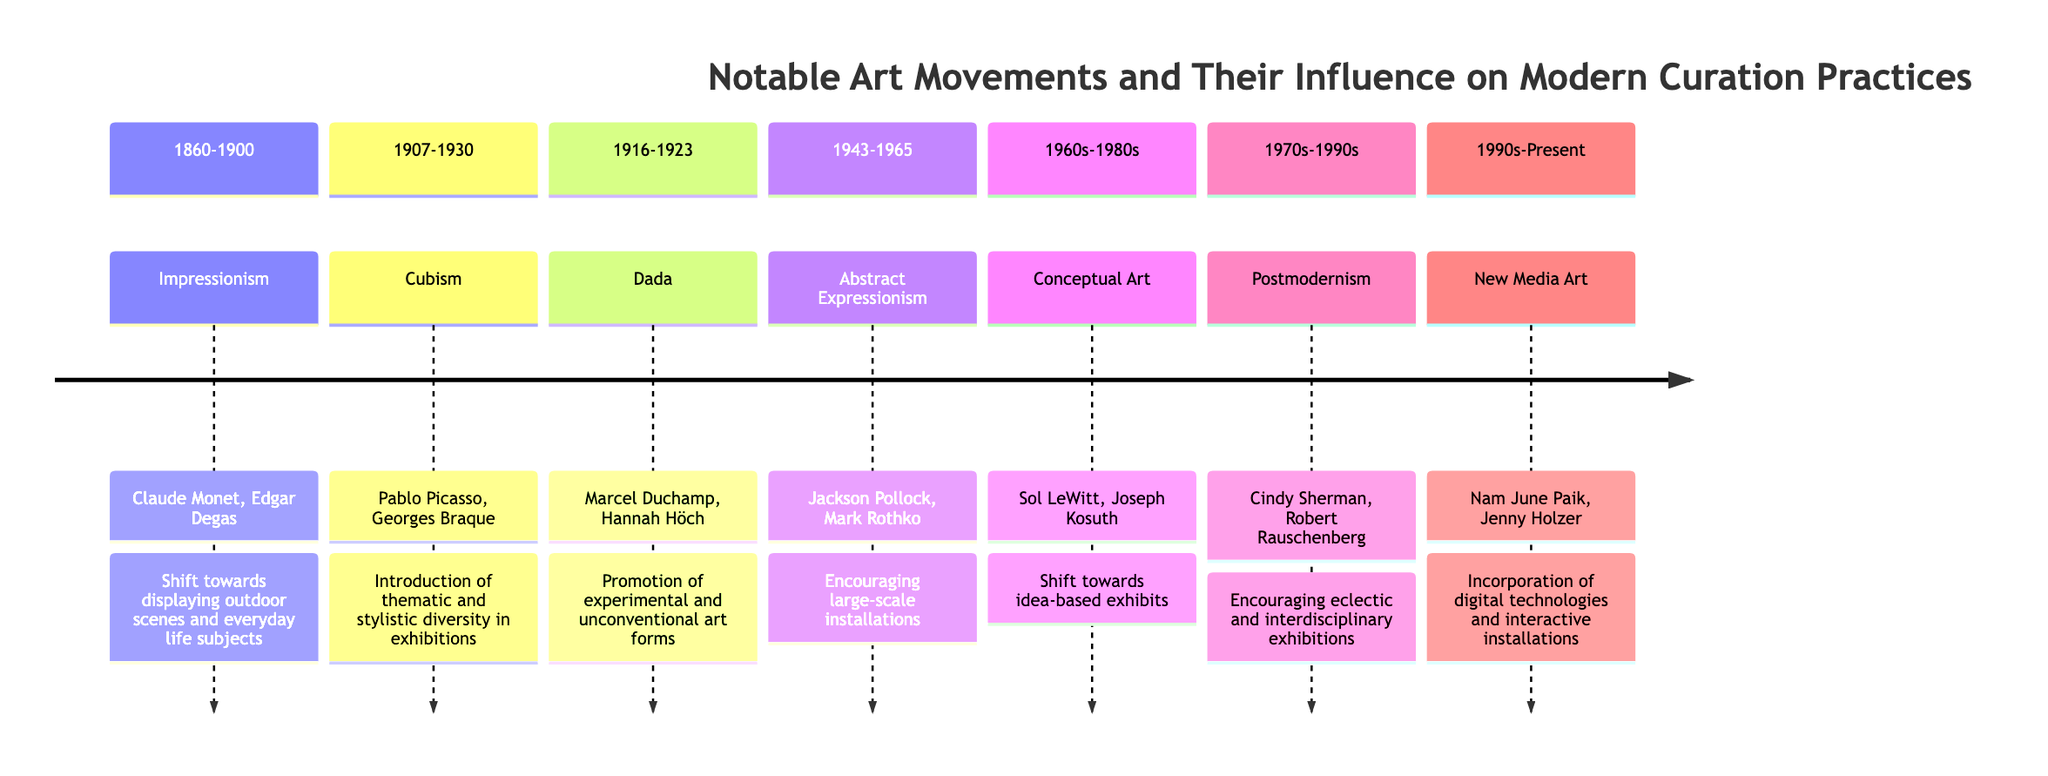What is the art movement from 1860-1900? According to the timeline, the movement that occurred during this period is Impressionism.
Answer: Impressionism Who are the founders of Cubism? In the diagram, the founders listed for Cubism are Pablo Picasso and Georges Braque.
Answer: Pablo Picasso, Georges Braque What influence did Dada have on modern curation? The timeline indicates that Dada promoted experimental and unconventional art forms, leading to dynamic and interactive exhibit spaces.
Answer: Experimental and unconventional art forms How many art movements are represented in the timeline? By counting each distinct art movement in the timeline, we see there are a total of seven movements listed.
Answer: 7 Which movement encouraged large-scale installations? The timeline specifies that Abstract Expressionism encouraged large-scale installations as part of its influence on curatorial practices.
Answer: Abstract Expressionism What period does New Media Art belong to? The diagram states that New Media Art is associated with the period from the 1990s to the present.
Answer: 1990s-Present What is the primary focus of Conceptual Art exhibitions? According to the timeline, Conceptual Art shifted the focus towards idea-based exhibits and the representation of the artistic process.
Answer: Idea-based exhibits Which movement challenged traditional narratives? The timeline notes that Postmodernism encouraged eclectic and interdisciplinary exhibitions, thereby challenging traditional narratives.
Answer: Postmodernism What is the influence of Impressionism on curation? The influence of Impressionism, as mentioned in the timeline, is a shift towards displaying outdoor scenes and everyday life subjects, enhancing public accessibility and engagement.
Answer: Outdoor scenes and everyday life subjects 